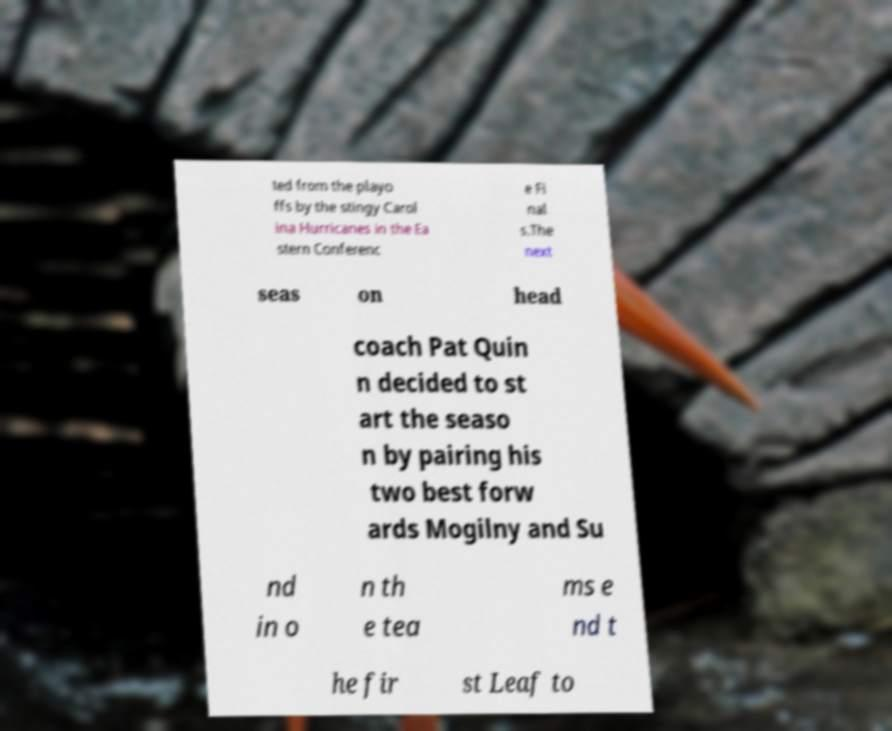Please read and relay the text visible in this image. What does it say? ted from the playo ffs by the stingy Carol ina Hurricanes in the Ea stern Conferenc e Fi nal s.The next seas on head coach Pat Quin n decided to st art the seaso n by pairing his two best forw ards Mogilny and Su nd in o n th e tea ms e nd t he fir st Leaf to 